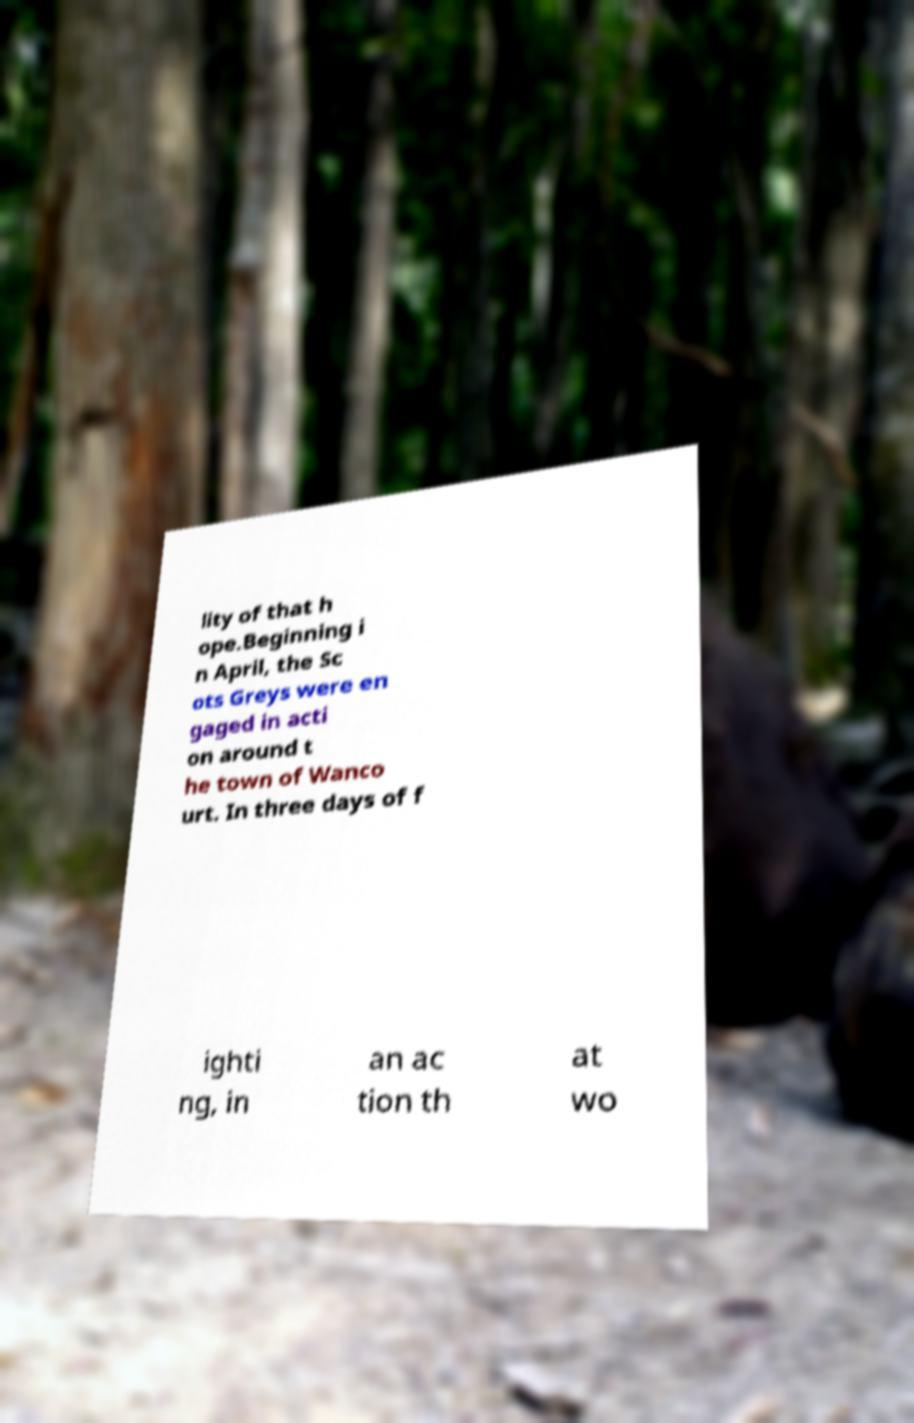For documentation purposes, I need the text within this image transcribed. Could you provide that? lity of that h ope.Beginning i n April, the Sc ots Greys were en gaged in acti on around t he town of Wanco urt. In three days of f ighti ng, in an ac tion th at wo 